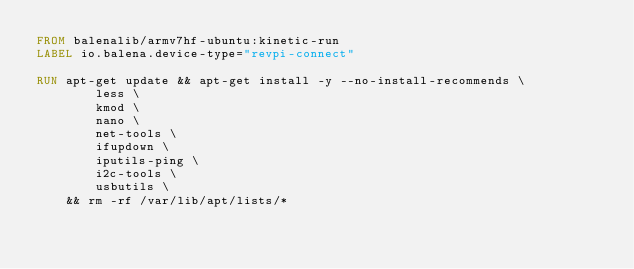<code> <loc_0><loc_0><loc_500><loc_500><_Dockerfile_>FROM balenalib/armv7hf-ubuntu:kinetic-run
LABEL io.balena.device-type="revpi-connect"

RUN apt-get update && apt-get install -y --no-install-recommends \
		less \
		kmod \
		nano \
		net-tools \
		ifupdown \
		iputils-ping \
		i2c-tools \
		usbutils \
	&& rm -rf /var/lib/apt/lists/*
</code> 